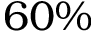Convert formula to latex. <formula><loc_0><loc_0><loc_500><loc_500>6 0 \%</formula> 